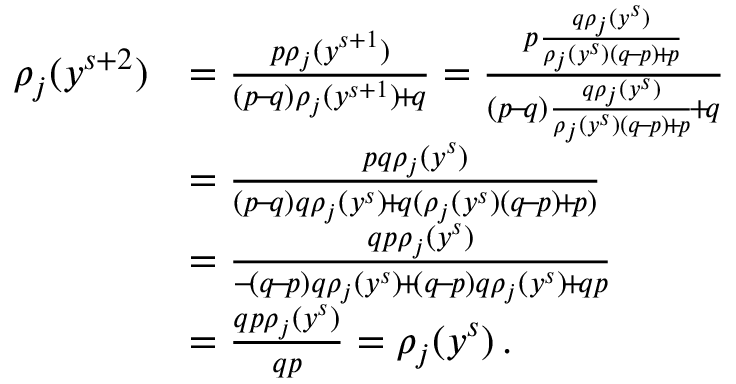Convert formula to latex. <formula><loc_0><loc_0><loc_500><loc_500>\begin{array} { r l } { \rho _ { j } ( y ^ { s + 2 } ) } & { = \frac { p \rho _ { j } ( y ^ { s + 1 } ) } { ( p \, - \, q ) \rho _ { j } ( y ^ { s + 1 } ) \, + \, q } = \frac { p \frac { q \rho _ { j } ( y ^ { s } ) } { \rho _ { j } ( y ^ { s } ) ( q \, - \, p ) \, + \, p } } { ( p \, - \, q ) \frac { q \rho _ { j } ( y ^ { s } ) } { \rho _ { j } ( y ^ { s } ) ( q \, - \, p ) \, + \, p } \, + \, q } } \\ & { = \frac { p q \rho _ { j } ( y ^ { s } ) } { ( p \, - \, q ) q \rho _ { j } ( y ^ { s } ) \, + \, q ( \rho _ { j } ( y ^ { s } ) ( q \, - \, p ) \, + \, p ) } } \\ & { = \frac { q p \rho _ { j } ( y ^ { s } ) } { - \, ( q \, - \, p ) q \rho _ { j } ( y ^ { s } ) \, + \, ( q \, - \, p ) q \rho _ { j } ( y ^ { s } ) \, + \, q p } } \\ & { = \frac { q p \rho _ { j } ( y ^ { s } ) } { q p } = \rho _ { j } ( y ^ { s } ) \, . } \end{array}</formula> 